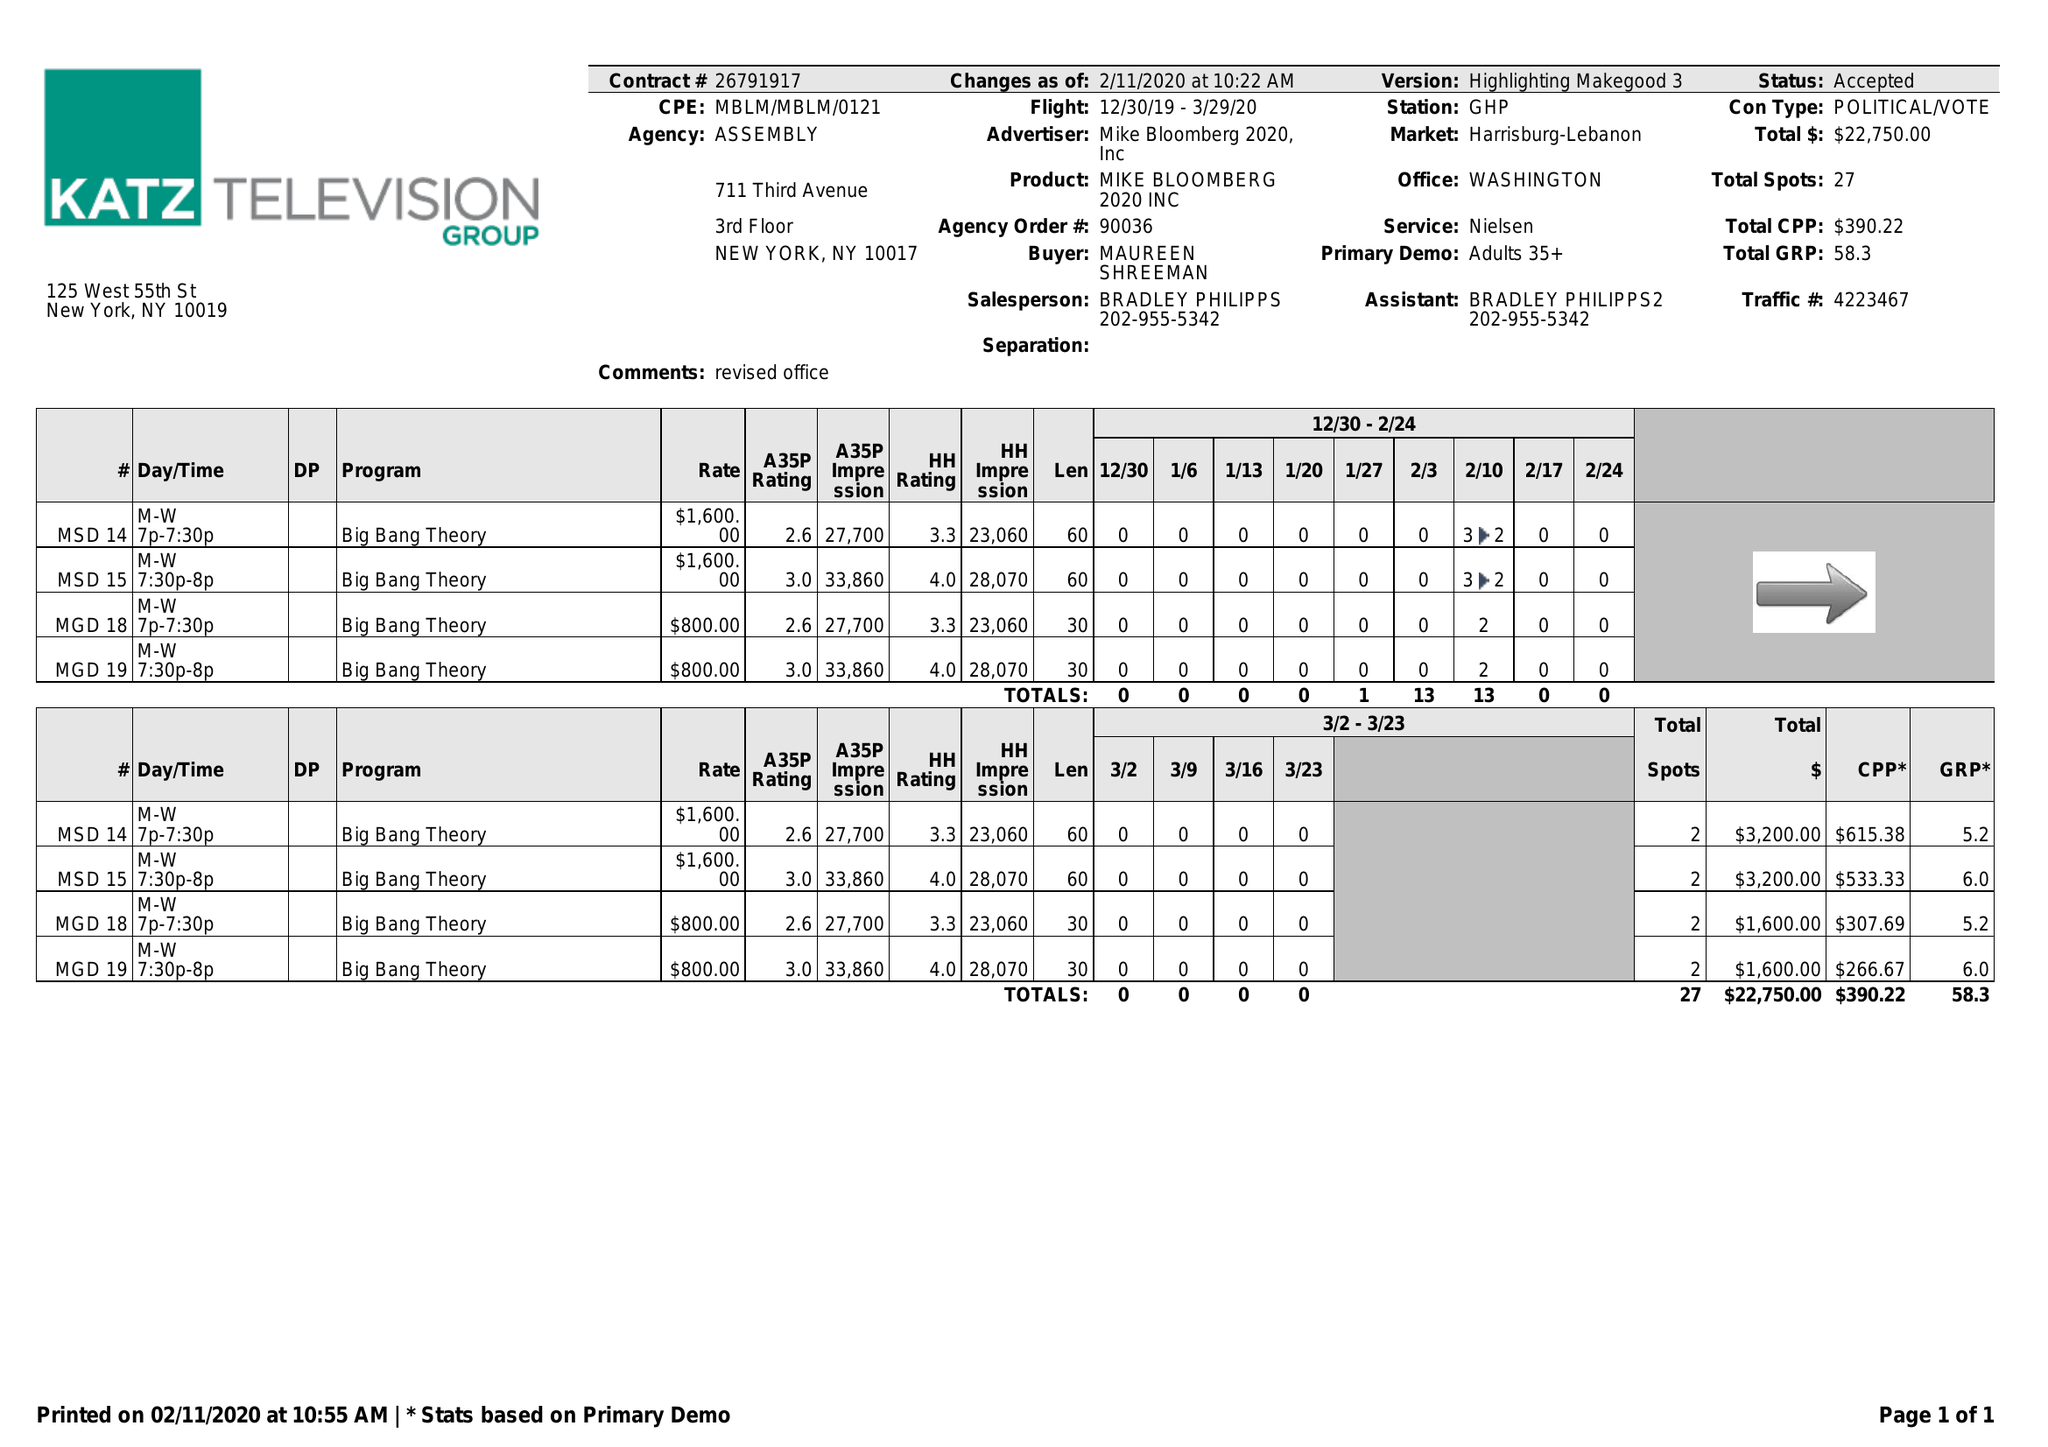What is the value for the contract_num?
Answer the question using a single word or phrase. 26791917 